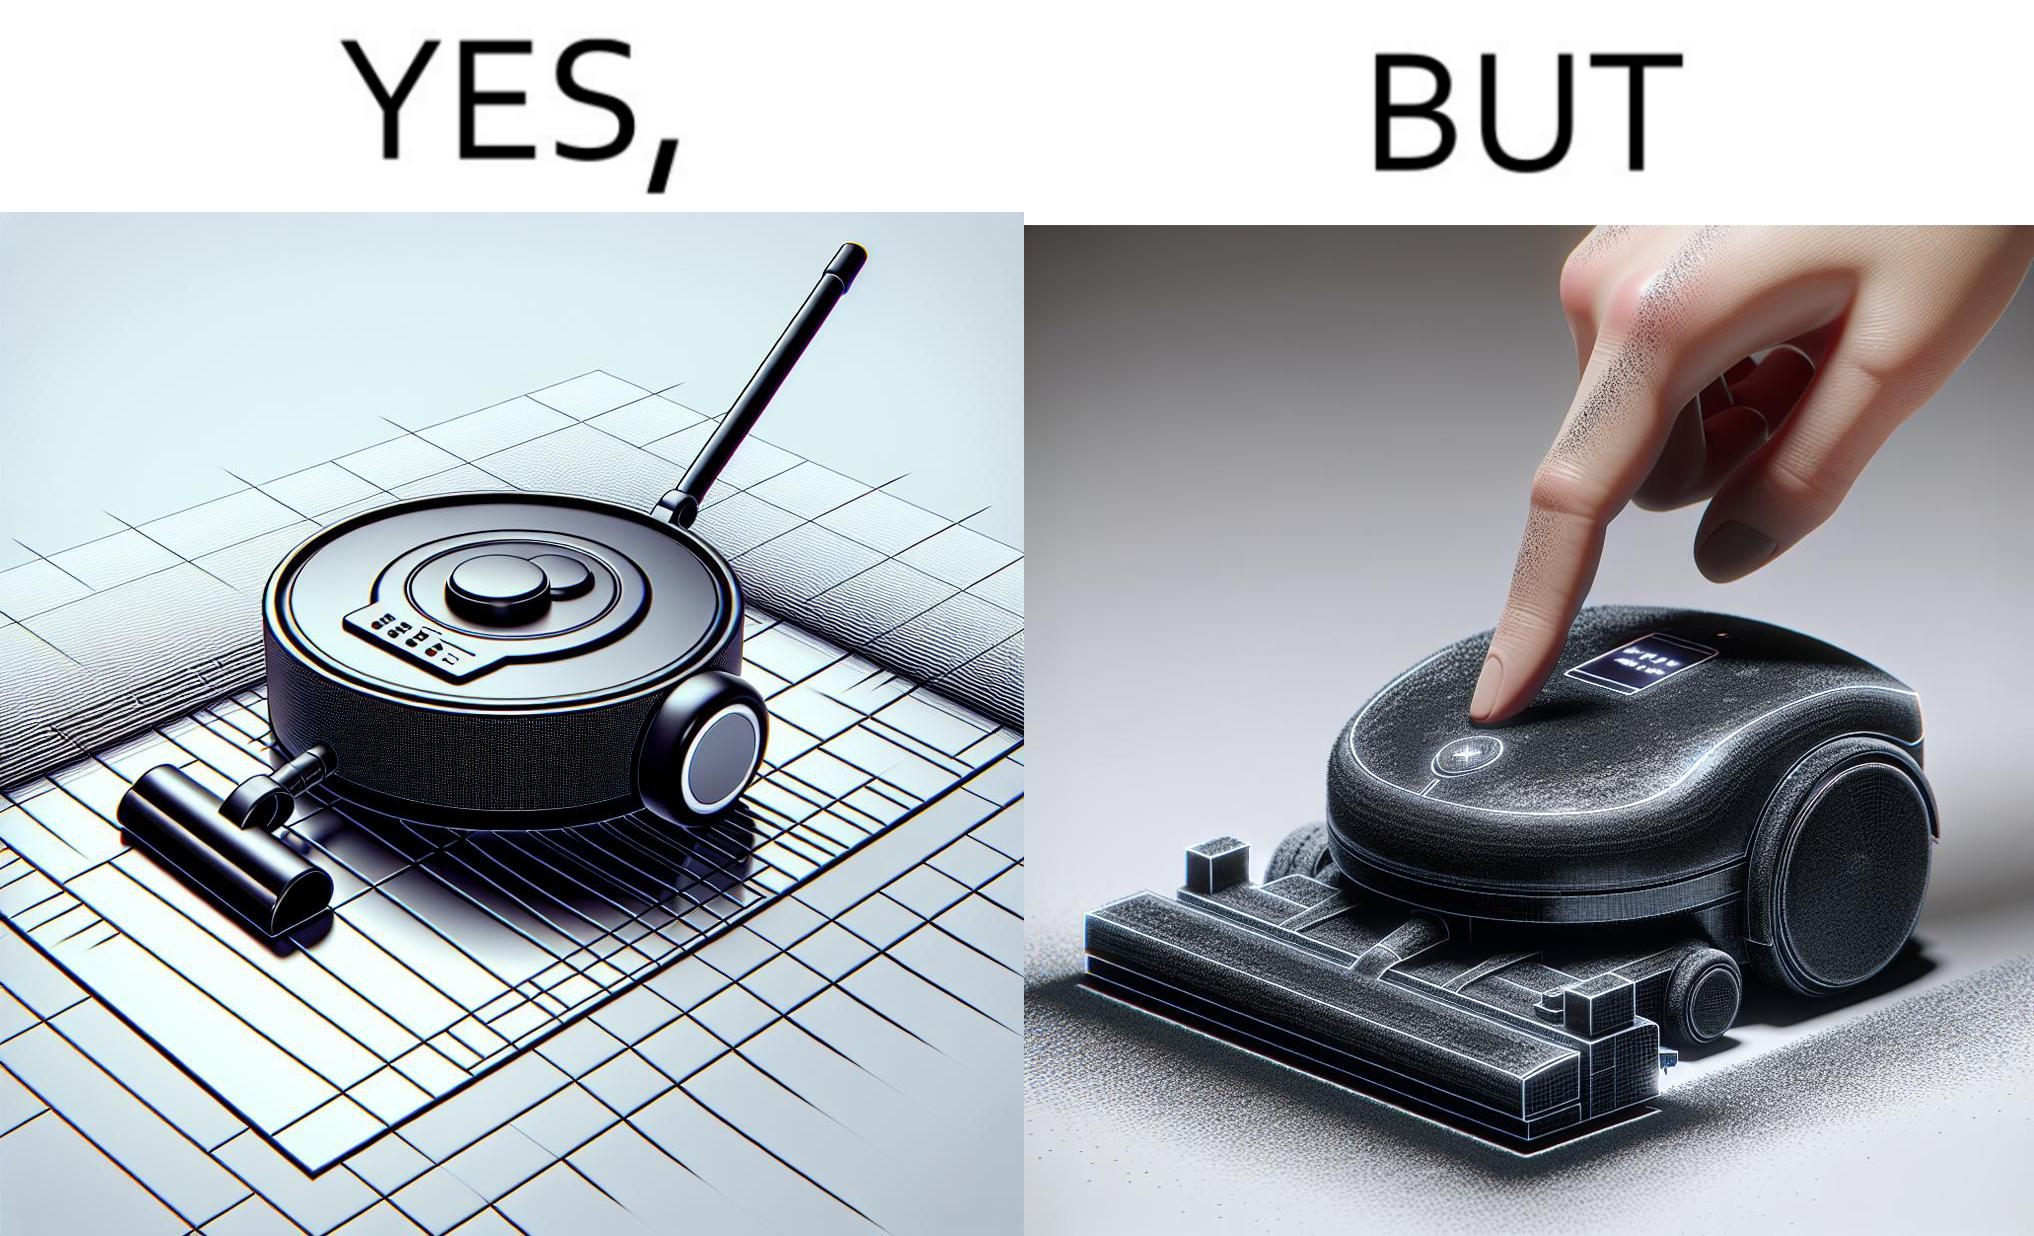Explain the humor or irony in this image. This is funny, because the machine while doing its job cleans everything but ends up being dirty itself. 